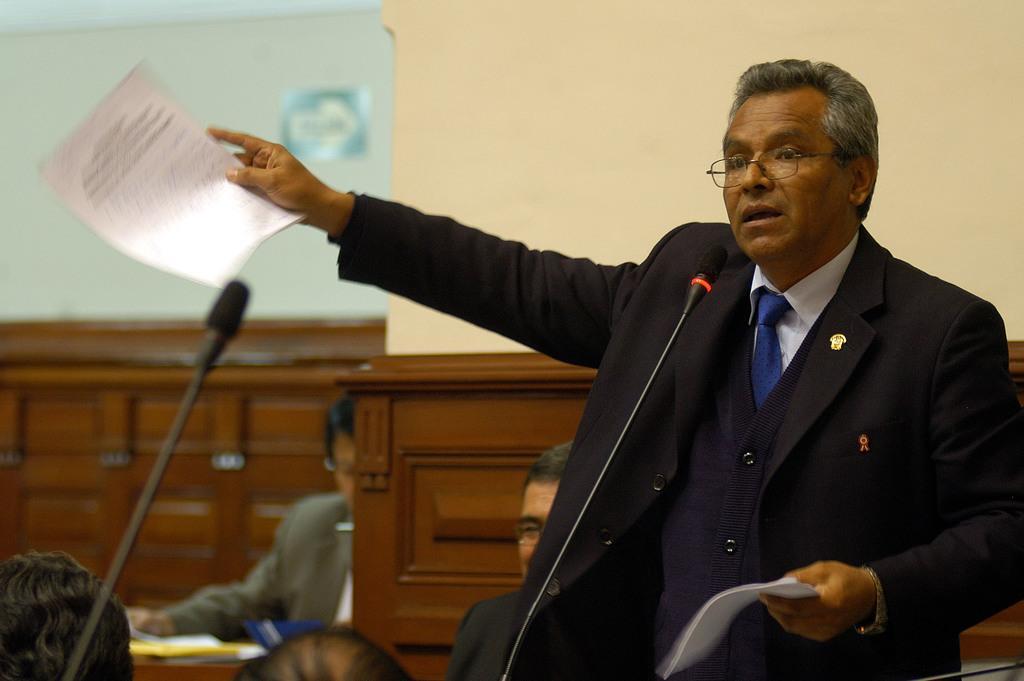Could you give a brief overview of what you see in this image? In this image there is one person standing on the right side of this image is holding some papers and there is a wall in the background. there are some persons sitting in the bottom left side of this image. 